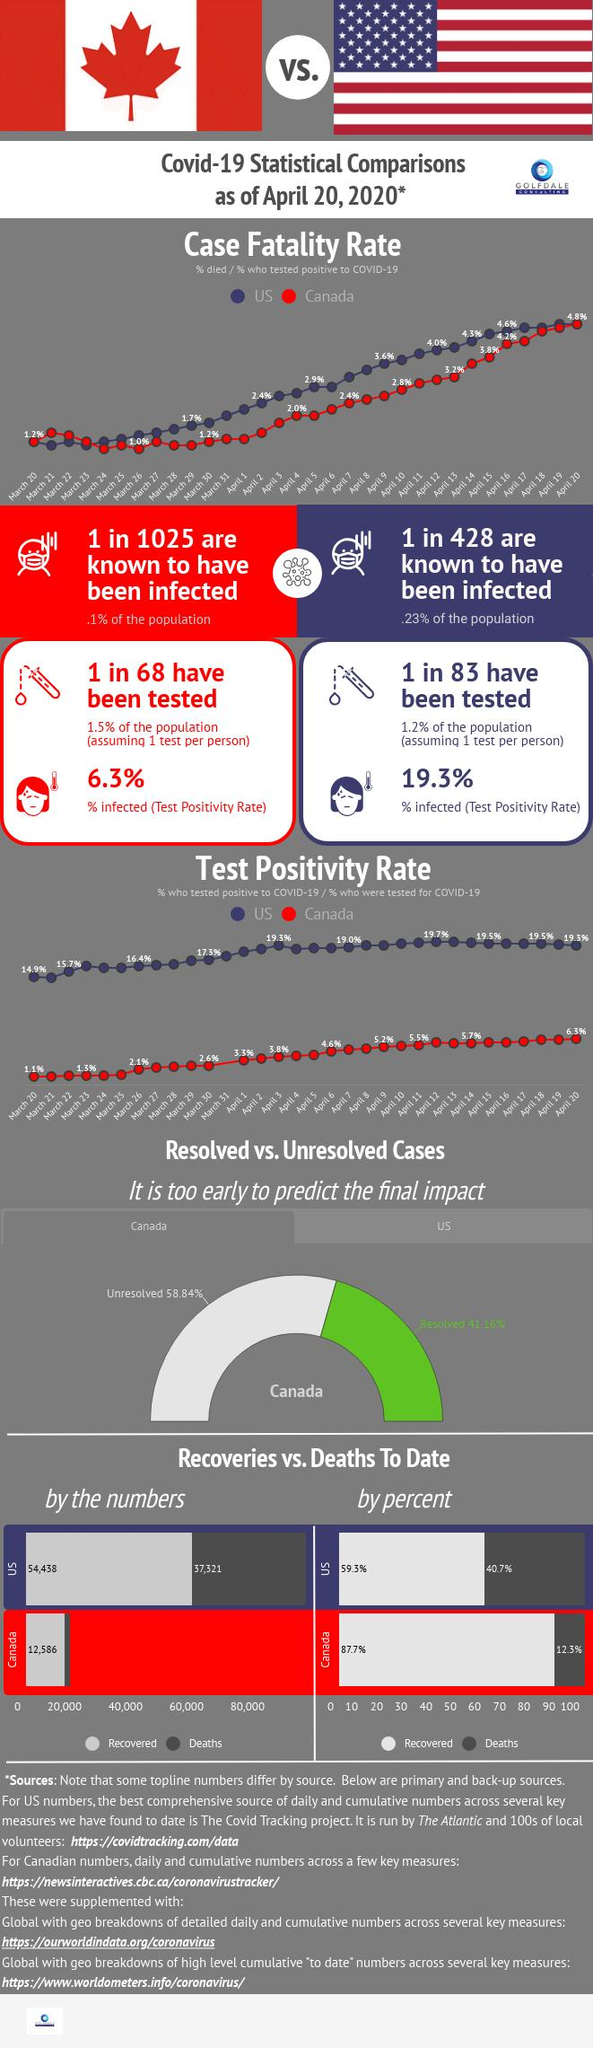Indicate a few pertinent items in this graphic. As of April 20, 2020, 54,438 cases of COVID-19 that had been successfully treated and recovered from had been reported in the United States. As of April 20, 2020, a total of 37,321 COVID-19 deaths have been reported in the United States. On April 16, 2020, the case fatality rate due to Covid-19 in the United States was 4.6%. As of April 20, 2020, the test positivity rate in Canada was 6.3%. The case fatality rate due to Covid-19 in Canada on March 26, 2020 was 1.0%. 